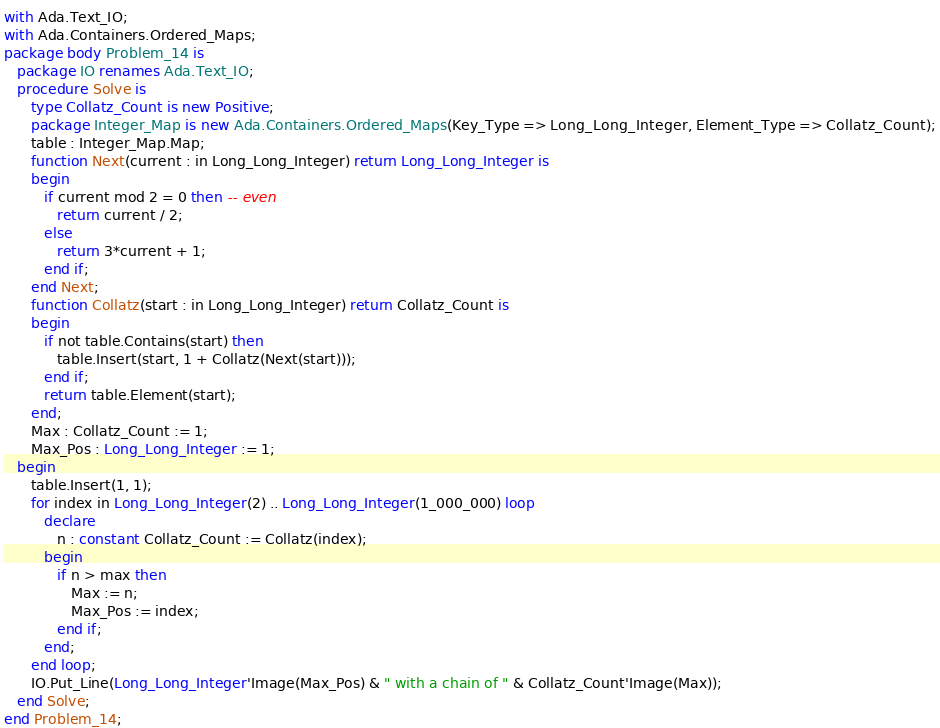Convert code to text. <code><loc_0><loc_0><loc_500><loc_500><_Ada_>with Ada.Text_IO;
with Ada.Containers.Ordered_Maps;
package body Problem_14 is
   package IO renames Ada.Text_IO;
   procedure Solve is
      type Collatz_Count is new Positive;
      package Integer_Map is new Ada.Containers.Ordered_Maps(Key_Type => Long_Long_Integer, Element_Type => Collatz_Count);
      table : Integer_Map.Map;
      function Next(current : in Long_Long_Integer) return Long_Long_Integer is
      begin
         if current mod 2 = 0 then -- even
            return current / 2;
         else
            return 3*current + 1;
         end if;
      end Next;
      function Collatz(start : in Long_Long_Integer) return Collatz_Count is
      begin
         if not table.Contains(start) then
            table.Insert(start, 1 + Collatz(Next(start)));
         end if;
         return table.Element(start);
      end;
      Max : Collatz_Count := 1;
      Max_Pos : Long_Long_Integer := 1;
   begin
      table.Insert(1, 1);
      for index in Long_Long_Integer(2) .. Long_Long_Integer(1_000_000) loop
         declare
            n : constant Collatz_Count := Collatz(index);
         begin
            if n > max then
               Max := n;
               Max_Pos := index;
            end if;
         end;
      end loop;
      IO.Put_Line(Long_Long_Integer'Image(Max_Pos) & " with a chain of " & Collatz_Count'Image(Max));
   end Solve;
end Problem_14;
</code> 